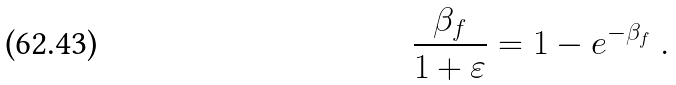<formula> <loc_0><loc_0><loc_500><loc_500>\frac { \beta _ { f } } { 1 + \varepsilon } = 1 - e ^ { - \beta _ { f } } \ .</formula> 